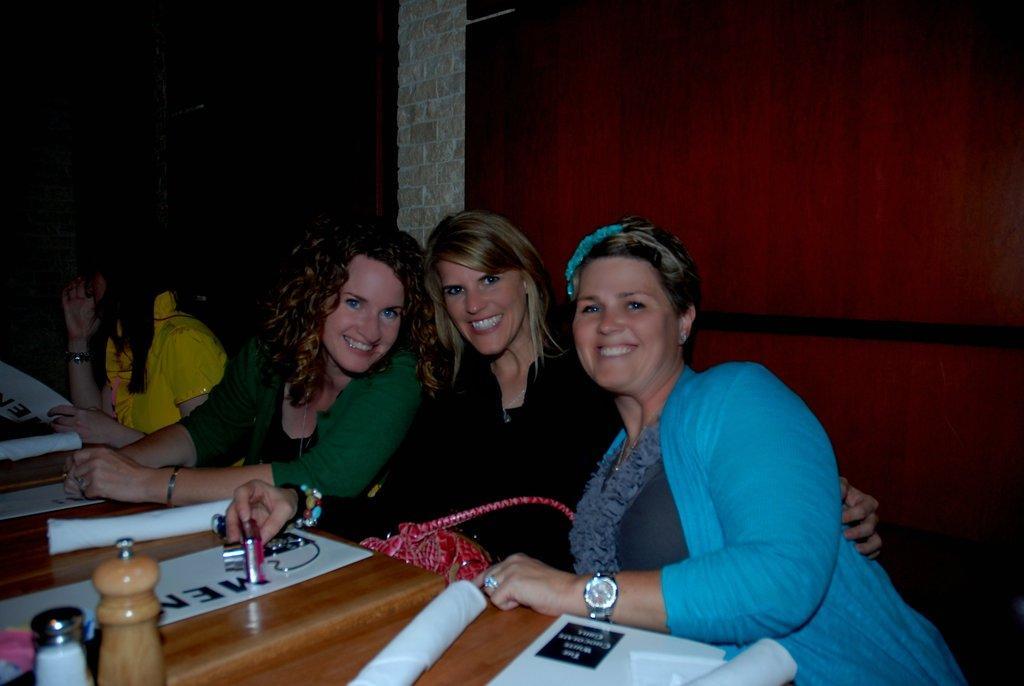Could you give a brief overview of what you see in this image? There are four ladies. In that black color dress wearing lady is holding a bag and a camera in her hand. Three of them are smiling. Blue color dress wearing lady is having a watch and hair band on her head. In the background it is red color. And there is a table. One the table there are some papers and bottles. 